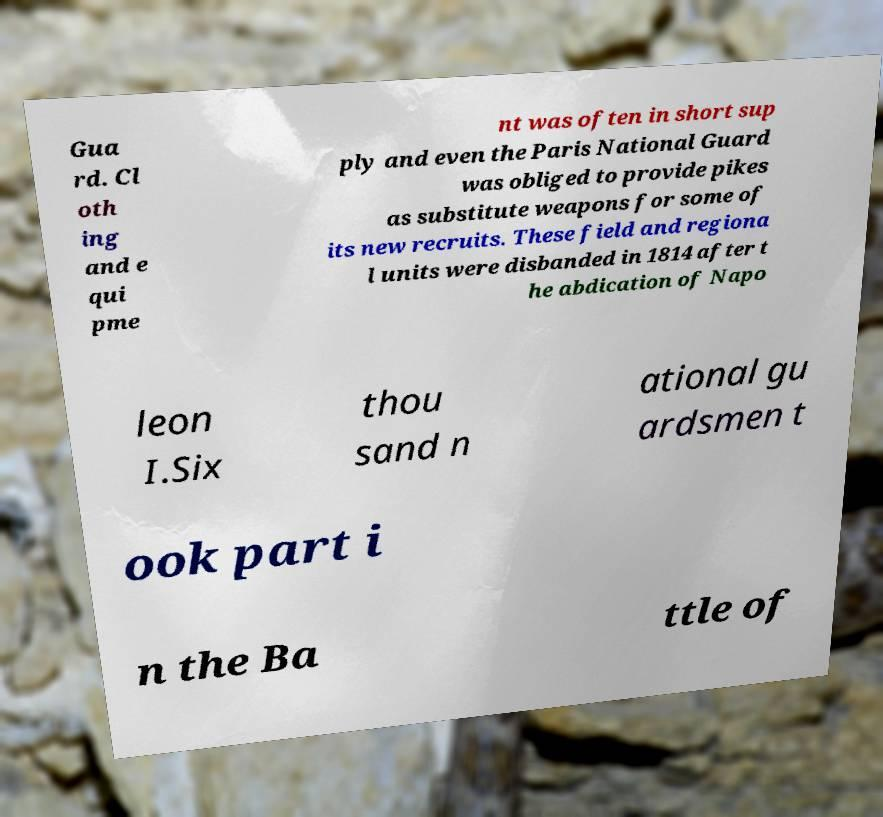Could you assist in decoding the text presented in this image and type it out clearly? Gua rd. Cl oth ing and e qui pme nt was often in short sup ply and even the Paris National Guard was obliged to provide pikes as substitute weapons for some of its new recruits. These field and regiona l units were disbanded in 1814 after t he abdication of Napo leon I.Six thou sand n ational gu ardsmen t ook part i n the Ba ttle of 